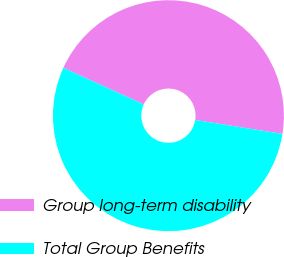Convert chart to OTSL. <chart><loc_0><loc_0><loc_500><loc_500><pie_chart><fcel>Group long-term disability<fcel>Total Group Benefits<nl><fcel>45.72%<fcel>54.28%<nl></chart> 